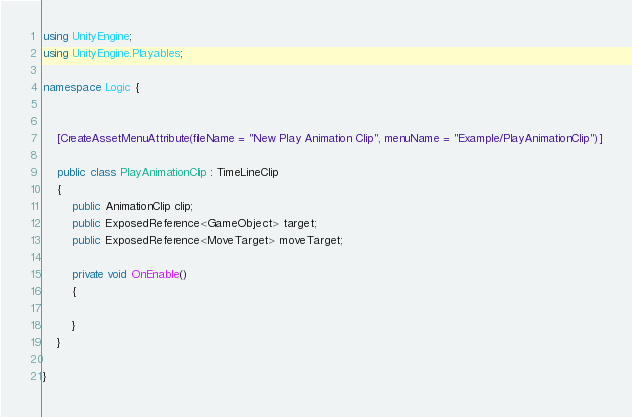Convert code to text. <code><loc_0><loc_0><loc_500><loc_500><_C#_>using UnityEngine;
using UnityEngine.Playables;

namespace Logic {


	[CreateAssetMenuAttribute(fileName = "New Play Animation Clip", menuName = "Example/PlayAnimationClip")]
	
	public class PlayAnimationClip : TimeLineClip
	{	
		public AnimationClip clip;
		public ExposedReference<GameObject> target;
		public ExposedReference<MoveTarget> moveTarget;
		
		private void OnEnable()
		{
			
		}
	}

}</code> 